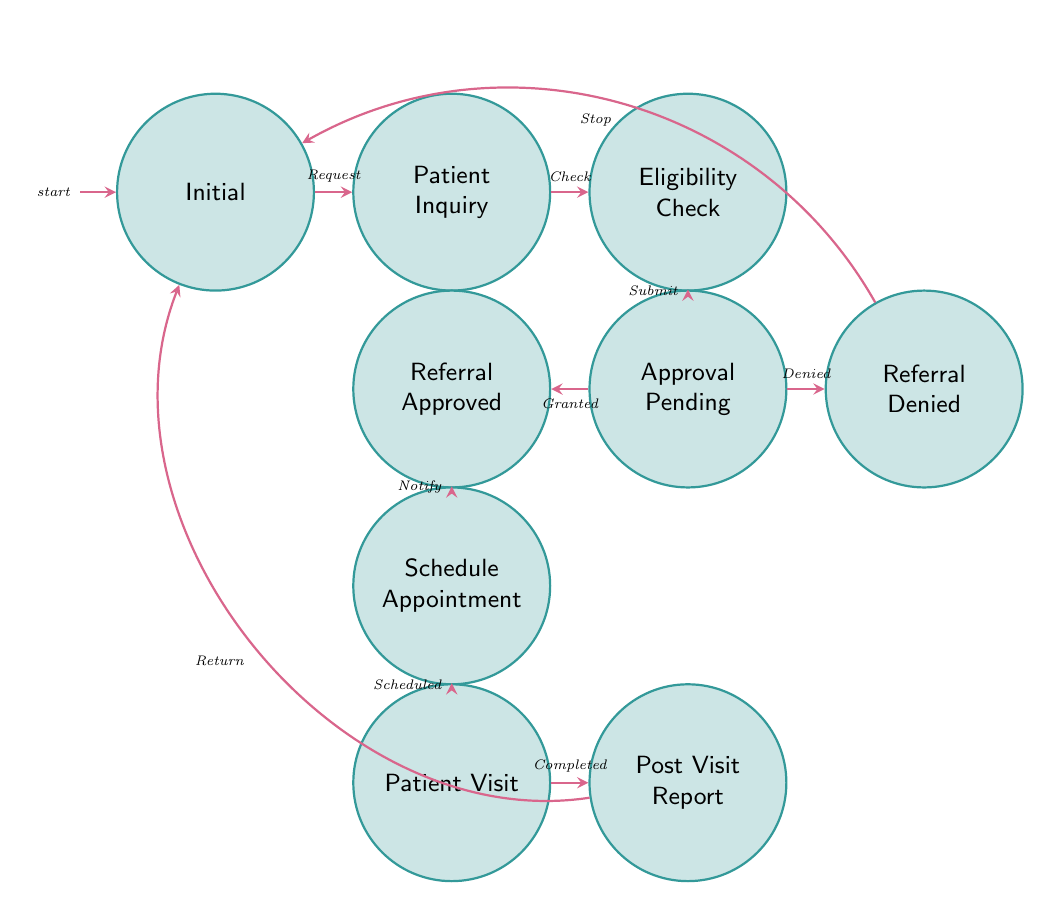What is the starting point in the referral process? The diagram indicates that the starting point is labeled as "Initial." This is the first state the process begins with.
Answer: Initial How many states are there in the diagram? By counting the distinct states listed in the diagram, there are nine states: Initial, Patient Inquiry, Eligibility Check, Approval Pending, Referral Approved, Referral Denied, Schedule Appointment, Patient Visit, and Post Visit Report.
Answer: 9 Which state follows the "Eligibility Check"? The transition arrows in the diagram show that after "Eligibility Check," the next state is "Approval Pending." The arrow from "Eligibility Check" points directly to "Approval Pending."
Answer: Approval Pending What triggers the transition to "Patient Visit"? The transition to "Patient Visit" occurs when the "Appointment scheduled" trigger is activated after the "Schedule Appointment" state. This is indicated by the arrow pointing from "Schedule Appointment" to "Patient Visit."
Answer: Appointment scheduled In which state does the process return to "Initial" after denial? The process returns to "Initial" after the "Referral Denied" state. The diagram shows a bend right arrow leading back to "Initial" after "Referral Denied."
Answer: Initial How many transitions lead out of the "Approval Pending" state? There are two transitions leading out of the "Approval Pending" state. One goes to "Referral Approved," and the other goes to "Referral Denied." Both transitions are shown with arrows branching from "Approval Pending."
Answer: 2 What happens after a "Patient visit completed"? After a "Patient visit completed," the next action is to generate a "Post Visit Report." The arrow from "Patient Visit" points to "Post Visit Report," indicating the subsequent step in the workflow.
Answer: Post Visit Report What is the response when a referral is denied? When a referral is denied, the workflow stops and returns to the "Initial" state, as shown by the arrow from "Referral Denied" directing back to "Initial."
Answer: Return to Initial How does the workflow end according to the diagram? The workflow ends after the "Post Visit Report" is sent to the primary care doctor, at which point there is a transition arrow that returns to the "Initial" state.
Answer: Returns to Initial 